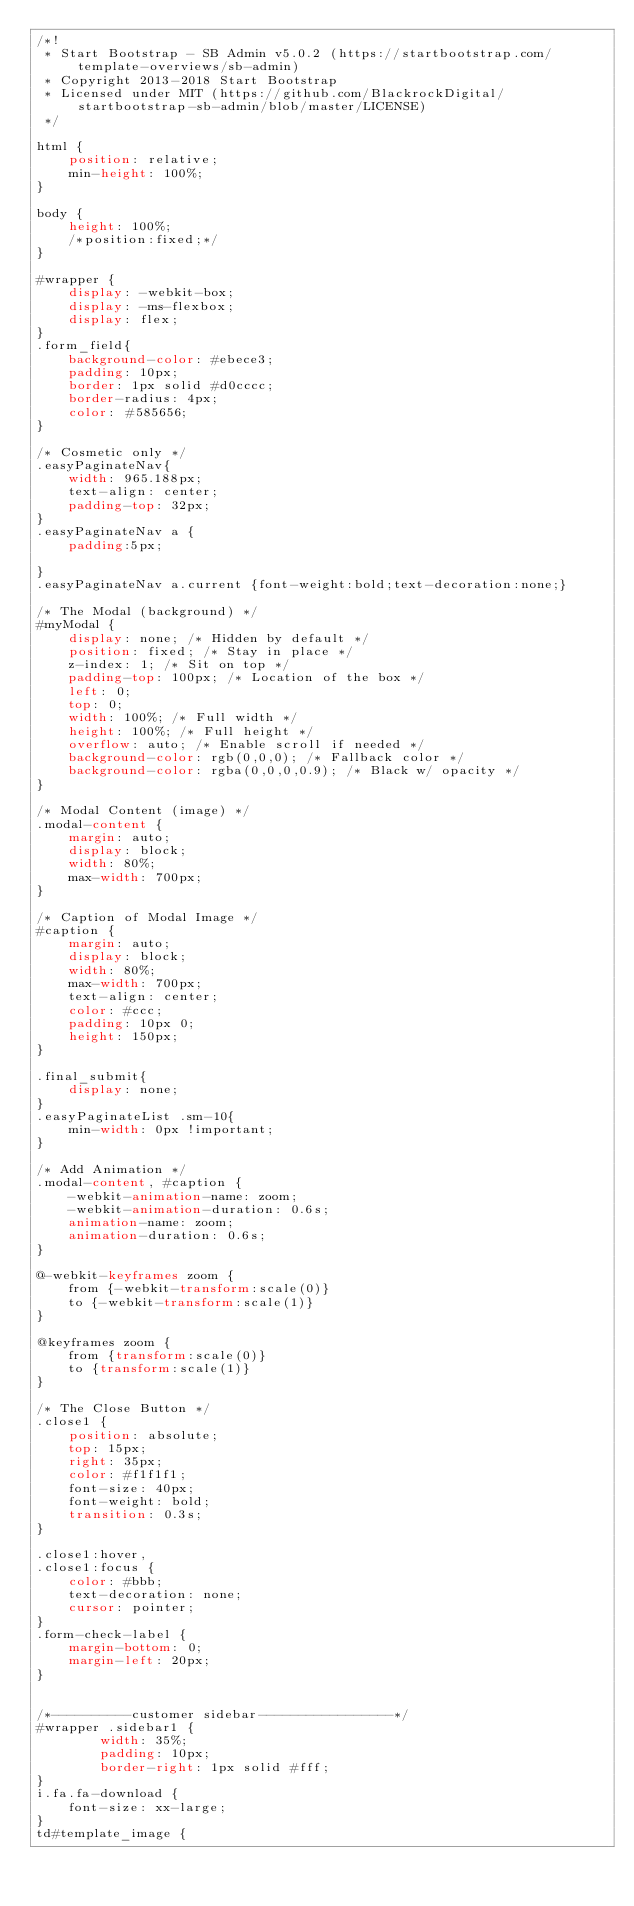<code> <loc_0><loc_0><loc_500><loc_500><_CSS_>/*!
 * Start Bootstrap - SB Admin v5.0.2 (https://startbootstrap.com/template-overviews/sb-admin)
 * Copyright 2013-2018 Start Bootstrap
 * Licensed under MIT (https://github.com/BlackrockDigital/startbootstrap-sb-admin/blob/master/LICENSE)
 */

html {
    position: relative;
    min-height: 100%;
}

body {
    height: 100%;
	/*position:fixed;*/
}

#wrapper {
    display: -webkit-box;
    display: -ms-flexbox;
    display: flex;
}
.form_field{
    background-color: #ebece3;
    padding: 10px;
    border: 1px solid #d0cccc;
    border-radius: 4px;
    color: #585656;
}

/* Cosmetic only */
.easyPaginateNav{
    width: 965.188px;
    text-align: center;
    padding-top: 32px;
}
.easyPaginateNav a {
    padding:5px;
        
}
.easyPaginateNav a.current {font-weight:bold;text-decoration:none;}

/* The Modal (background) */
#myModal {
    display: none; /* Hidden by default */
    position: fixed; /* Stay in place */
    z-index: 1; /* Sit on top */
    padding-top: 100px; /* Location of the box */
    left: 0;
    top: 0;
    width: 100%; /* Full width */
    height: 100%; /* Full height */
    overflow: auto; /* Enable scroll if needed */
    background-color: rgb(0,0,0); /* Fallback color */
    background-color: rgba(0,0,0,0.9); /* Black w/ opacity */
}

/* Modal Content (image) */
.modal-content {
    margin: auto;
    display: block;
    width: 80%;
    max-width: 700px;
}

/* Caption of Modal Image */
#caption {
    margin: auto;
    display: block;
    width: 80%;
    max-width: 700px;
    text-align: center;
    color: #ccc;
    padding: 10px 0;
    height: 150px;
}

.final_submit{
    display: none;
}
.easyPaginateList .sm-10{
    min-width: 0px !important;
}

/* Add Animation */
.modal-content, #caption {    
    -webkit-animation-name: zoom;
    -webkit-animation-duration: 0.6s;
    animation-name: zoom;
    animation-duration: 0.6s;
}

@-webkit-keyframes zoom {
    from {-webkit-transform:scale(0)} 
    to {-webkit-transform:scale(1)}
}

@keyframes zoom {
    from {transform:scale(0)} 
    to {transform:scale(1)}
}

/* The Close Button */
.close1 {
    position: absolute;
    top: 15px;
    right: 35px;
    color: #f1f1f1;
    font-size: 40px;
    font-weight: bold;
    transition: 0.3s;
}

.close1:hover,
.close1:focus {
    color: #bbb;
    text-decoration: none;
    cursor: pointer;
}
.form-check-label {
    margin-bottom: 0;
    margin-left: 20px;
}


/*----------customer sidebar-----------------*/
#wrapper .sidebar1 {
        width: 35%;
        padding: 10px;
		border-right: 1px solid #fff;
}
i.fa.fa-download {
    font-size: xx-large;
}
td#template_image {</code> 